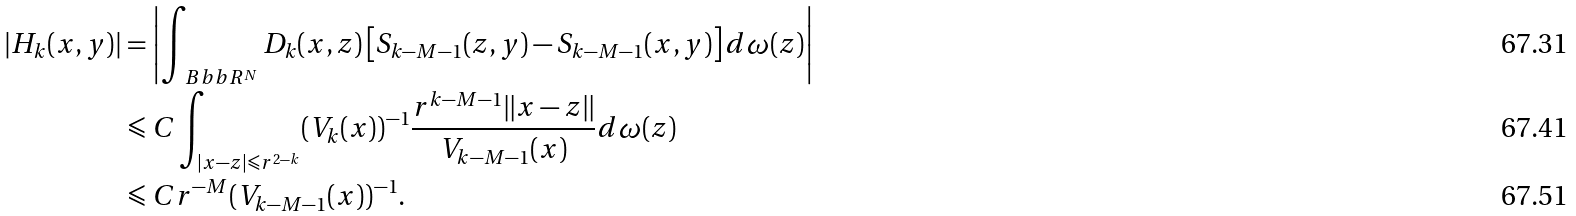<formula> <loc_0><loc_0><loc_500><loc_500>| H _ { k } ( x , y ) | & = \left | \int _ { \ B b b R ^ { N } } D _ { k } ( x , z ) \left [ S _ { k - M - 1 } ( z , y ) - S _ { k - M - 1 } ( x , y ) \right ] d \omega ( z ) \right | \\ & \leqslant C \int _ { | x - z | \leqslant r ^ { 2 - k } } ( V _ { k } ( x ) ) ^ { - 1 } \frac { r ^ { k - M - 1 } \| x - z \| } { V _ { k - M - 1 } ( x ) } d \omega ( z ) \\ & \leqslant C r ^ { - M } ( V _ { k - M - 1 } ( x ) ) ^ { - 1 } .</formula> 